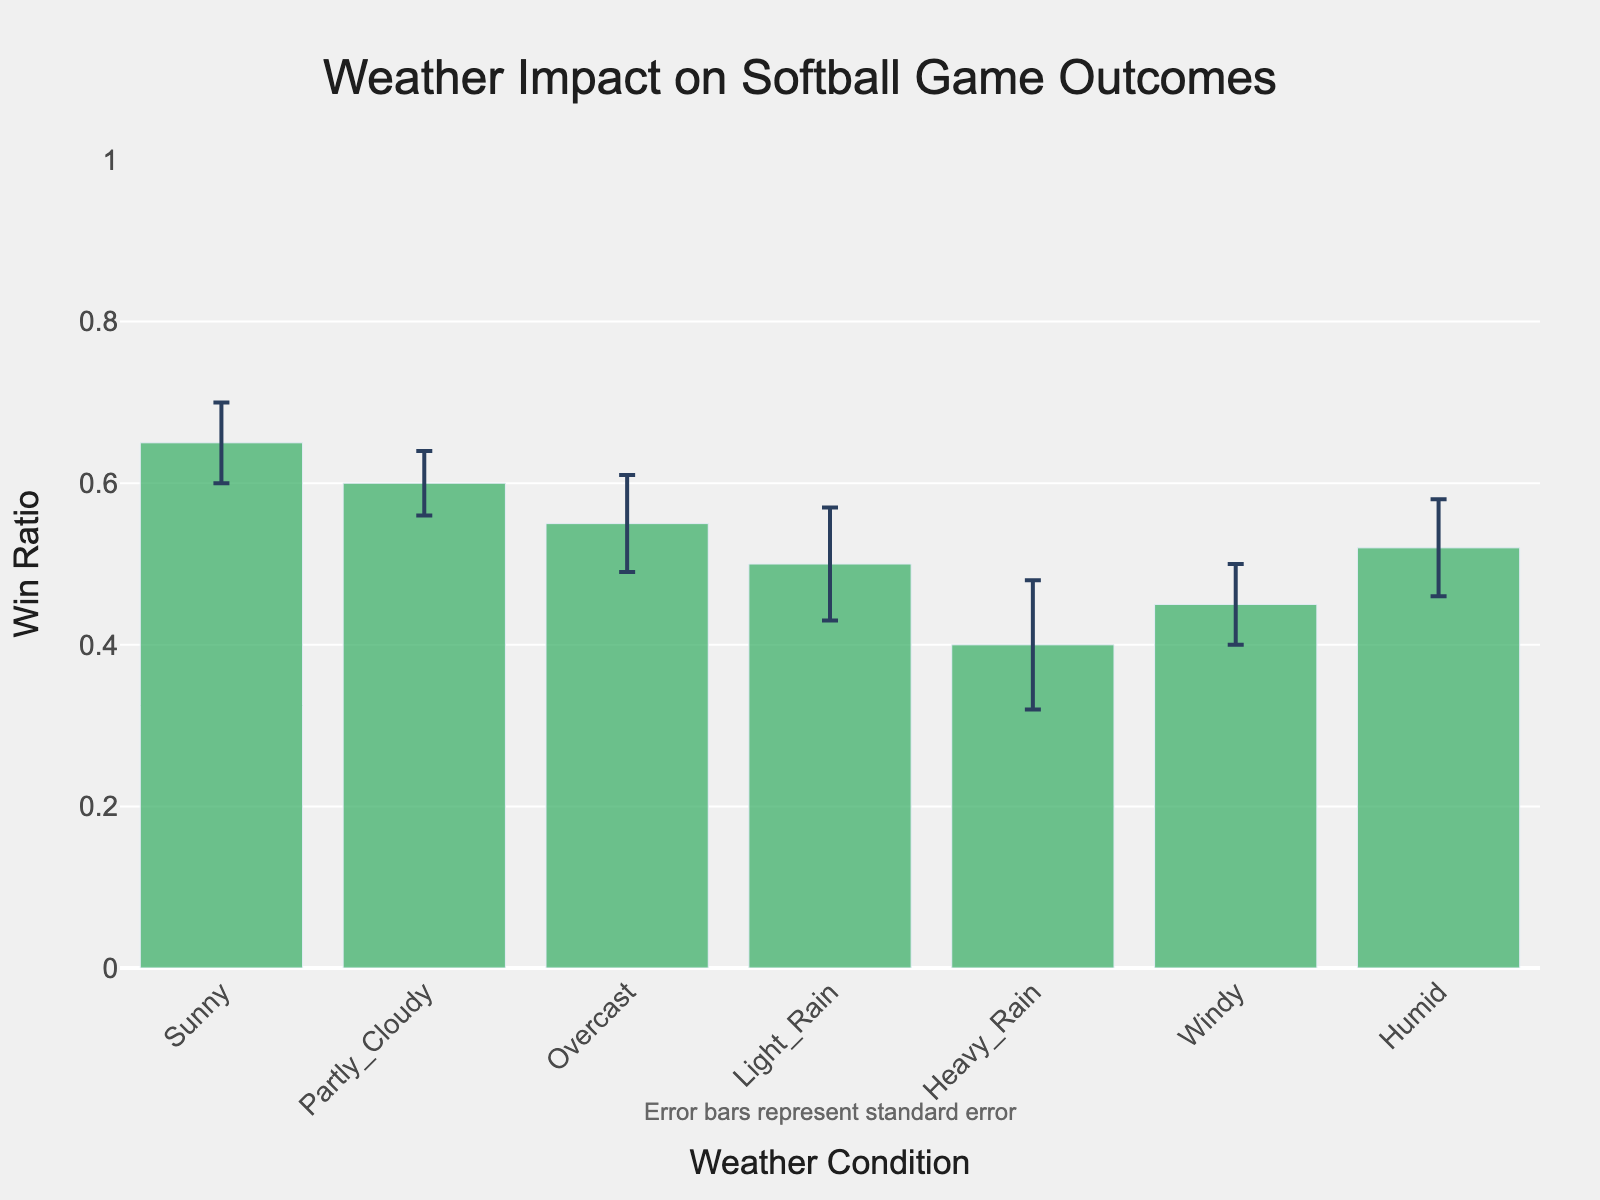What's the title of the plot? The title is located at the top center of the figure and reads: "Weather Impact on Softball Game Outcomes"
Answer: Weather Impact on Softball Game Outcomes What is the win ratio for games played in sunny weather? The win ratio is one of the data points presented on the bar chart, specifically for the "Sunny" condition. Based on its bar height, the win ratio for "Sunny" is 0.65
Answer: 0.65 Which weather condition has the highest win ratio? To find the highest win ratio, compare the heights of all the bars. The "Sunny" condition has the tallest bar, indicating the highest win ratio.
Answer: Sunny Which weather condition has the lowest win ratio? Compare all the bars and identify the shortest one. The "Heavy_Rain" condition has the lowest bar, indicating the lowest win ratio.
Answer: Heavy_Rain What is the win ratio error for "Windy" conditions? The error for each condition is provided as an error bar above each bar. The "Windy" condition has a win ratio error of 0.05.
Answer: 0.05 How does the win ratio for "Partly_Cloudy" compare to "Overcast"? The win ratio for "Partly_Cloudy" is 0.60, which you can see is taller than the bar for "Overcast," which has a win ratio of 0.55. This means "Partly_Cloudy" has a higher win ratio than "Overcast."
Answer: Partly_Cloudy has a higher win ratio than Overcast What is the average win ratio for all the weather conditions shown? To find the average, sum the win ratios for all conditions and divide by the number of conditions: (0.65 + 0.60 + 0.55 + 0.50 + 0.40 + 0.45 + 0.52) / 7 = 3.67 / 7 ≈ 0.52
Answer: 0.52 Which conditions have a win ratio above the average? The average win ratio is 0.52. Conditions with win ratios above this value are: "Sunny" (0.65), "Partly_Cloudy" (0.60), and "Overcast" (0.55).
Answer: Sunny, Partly_Cloudy, Overcast Which condition has the largest error bar? The largest error bar can be identified by checking the length of error bars. The "Heavy_Rain" condition has the largest error bar of 0.08.
Answer: Heavy_Rain What is the difference in win ratio between "Sunny" and "Heavy_Rain" conditions? The win ratio for "Sunny" is 0.65 and for "Heavy_Rain" is 0.40. The difference between these two is 0.65 - 0.40 = 0.25.
Answer: 0.25 